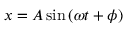Convert formula to latex. <formula><loc_0><loc_0><loc_500><loc_500>x = A \sin \left ( \omega t + \phi \right )</formula> 